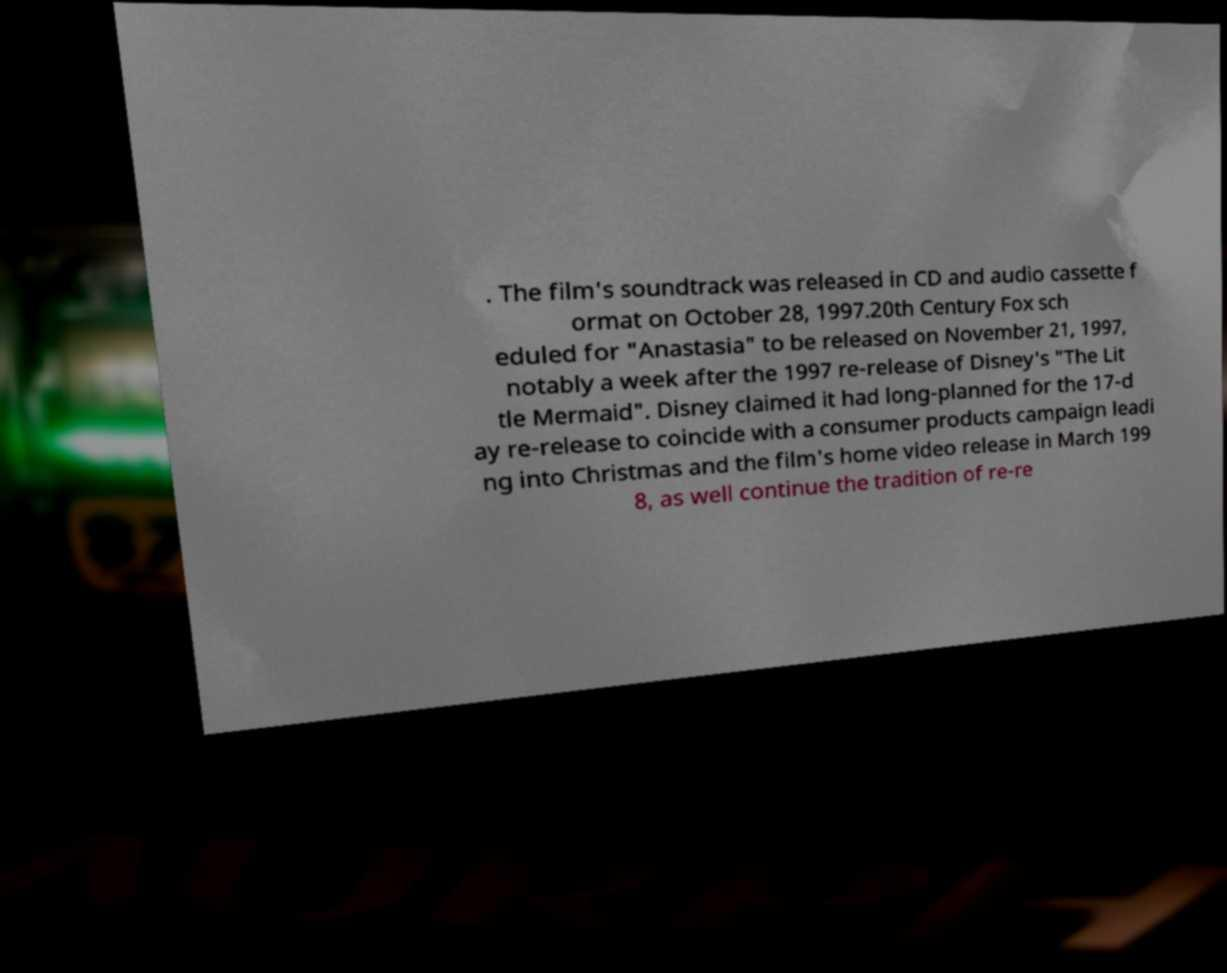Please read and relay the text visible in this image. What does it say? . The film's soundtrack was released in CD and audio cassette f ormat on October 28, 1997.20th Century Fox sch eduled for "Anastasia" to be released on November 21, 1997, notably a week after the 1997 re-release of Disney's "The Lit tle Mermaid". Disney claimed it had long-planned for the 17-d ay re-release to coincide with a consumer products campaign leadi ng into Christmas and the film's home video release in March 199 8, as well continue the tradition of re-re 